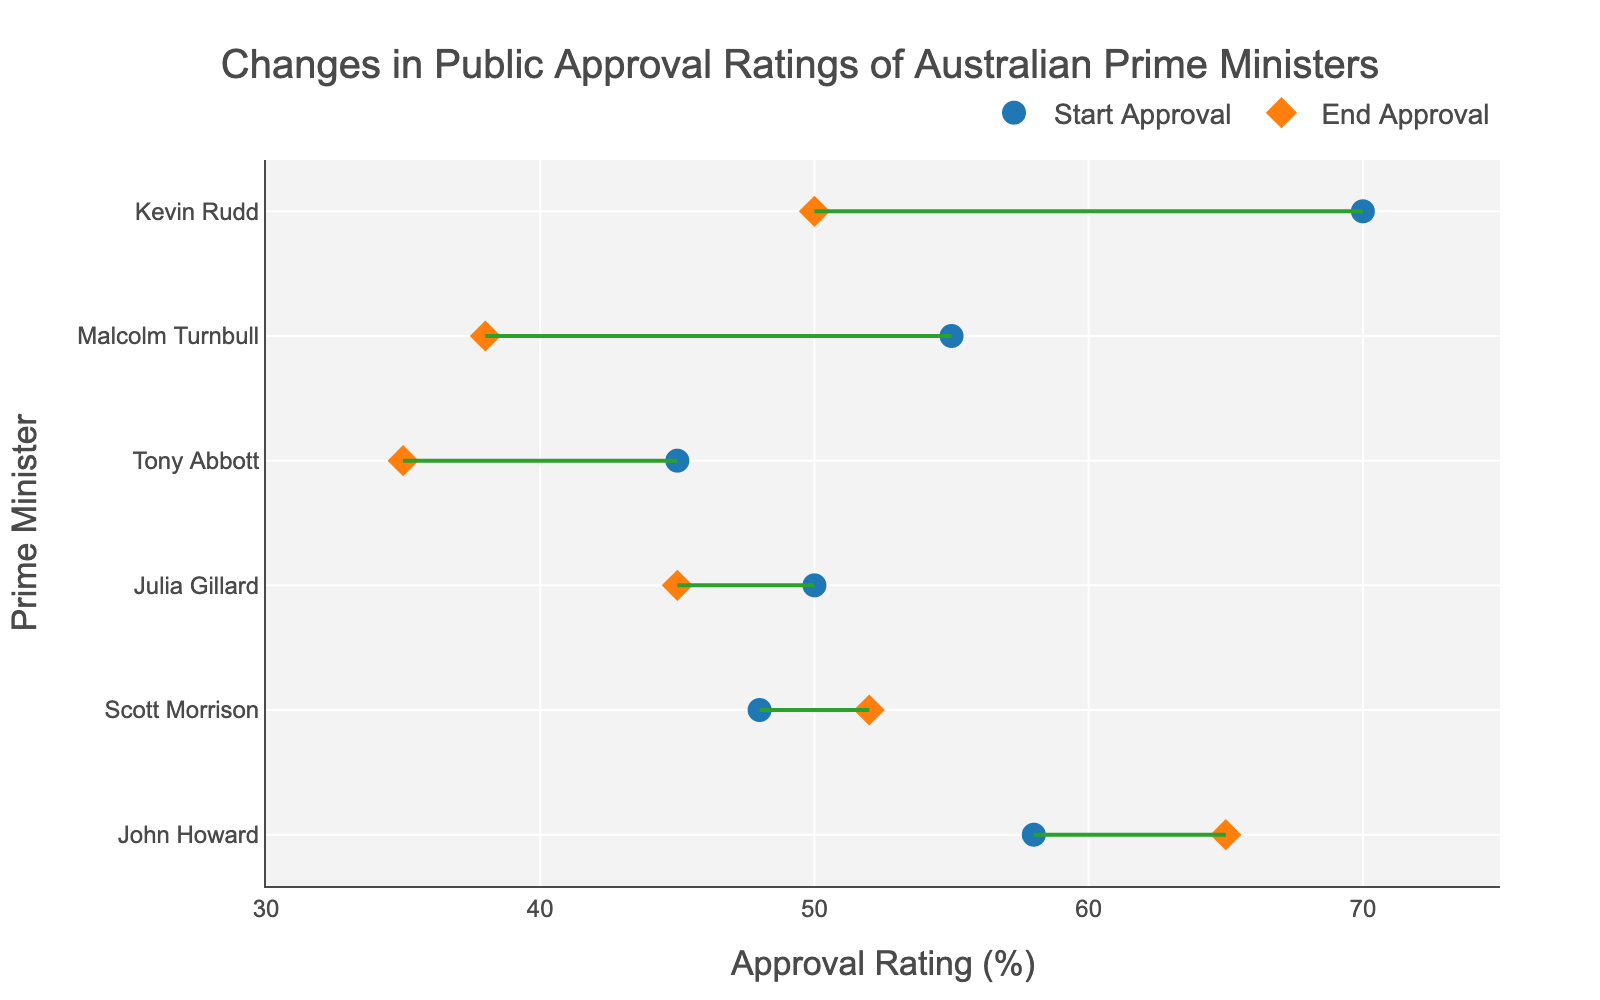How many Prime Ministers are shown in the plot? Count the number of distinct Prime Ministers listed on the y-axis.
Answer: 6 Which Prime Minister started with the highest approval rating? Identify the Prime Minister with the highest value on the x-axis for the "Start Approval" markers.
Answer: Kevin Rudd Which Prime Minister ended with the lowest approval rating? Identify the Prime Minister with the lowest value on the x-axis for the "End Approval" markers.
Answer: Tony Abbott Which Prime Minister experienced the greatest increase in approval rating? Compare the differences between start and end approval ratings for each Prime Minister to find the one with the largest positive difference.
Answer: John Howard What is the difference between Scott Morrison's start and end approval ratings? Subtract Scott Morrison's start approval rating from his end approval rating: 52 - 48.
Answer: 4 Who had a larger drop in approval rating, Kevin Rudd or Malcolm Turnbull? Calculate the drop for both: Kevin Rudd (70 - 50) and Malcolm Turnbull (55 - 38), then compare the two differences.
Answer: Kevin Rudd What is the average end approval rating of all Prime Ministers? Sum all End Approval values and divide by the number of Prime Ministers: (65 + 50 + 45 + 35 + 38 + 52)/6.
Answer: 47.5 What trend can be observed from the lines connecting the start and end approval ratings? Determine the general direction (increasing, decreasing, or stable) of the lines connecting start and end approval markers for most Prime Ministers.
Answer: Mostly decreasing Which Prime Minister had their start and end approval ratings closest to each other? Identify the Prime Minister with the smallest absolute difference between start and end approval ratings.
Answer: Scott Morrison Between Julia Gillard and Tony Abbott, who had a higher start approval rating and who had a higher end approval rating? Compare the start approval ratings and end approval ratings of Julia Gillard and Tony Abbott.
Answer: Julia Gillard (higher start), Julia Gillard (higher end) 